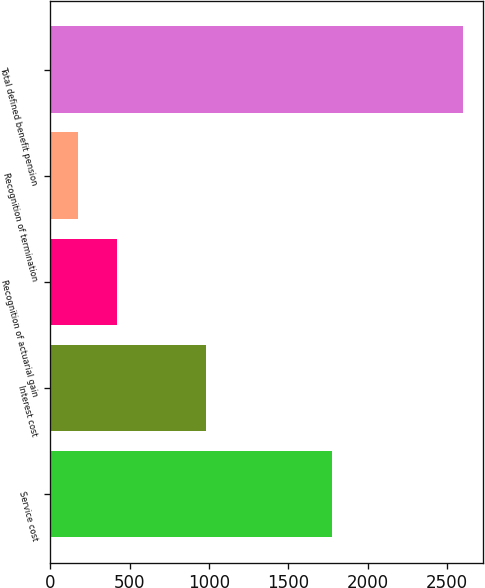<chart> <loc_0><loc_0><loc_500><loc_500><bar_chart><fcel>Service cost<fcel>Interest cost<fcel>Recognition of actuarial gain<fcel>Recognition of termination<fcel>Total defined benefit pension<nl><fcel>1775<fcel>980<fcel>417.5<fcel>175<fcel>2600<nl></chart> 